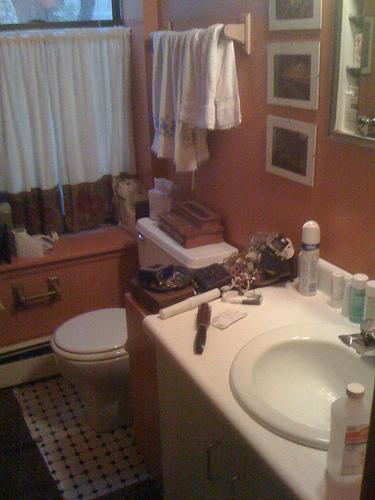What type of flooring does the bathroom have? The bathroom features a black and white checkered tile flooring that contrasts nicely with the pink wall. Describe the types of objects that can be found around the sink area. Around the sink, there are several bottles, a hairbrush, a spray bottle, and a bottle of alcohol, all placed on the white counter. Describe at least two personal care items found in the image. A pink and black hairbrush is on the counter near the sink, and a tissue box sits on top of the toilet. Narrate the overall ambiance and color scheme of the image. A soft, pink wall sets a warm tone for the bathroom, complemented by white fixtures and towels, as well as black and white checkered tile flooring. Provide a brief summary of the entire scene in the image. The bathroom has a white sink, toilet, and shower curtain, with a checkered floor, pink wall, towels on a rack, and various bottles and accessories on the counter. What is hanging on the wall and in what colors? Framed pictures in various sizes are hung on the wall, featuring a mix of white and dark frames. Mention the various storage items seen in the image. Cabinets with grey metal handles, a ledge for toilet paper, and a rack for hanging towels are noticeable storage items in the bathroom. Tell us what complements the white porcelain toilet in the bathroom. An empty wooden toilet paper holder and a tissue box on top provide complementary accents to the white porcelain toilet. How are the curtains in the image situated? White curtains cover the window, slightly parted to allow some sunlight to stream into the room. Point out the items that contribute to the bathroom's cleanliness. White towels hang neatly on a rack, and a spray bottle for cleaning is placed near the sink. 